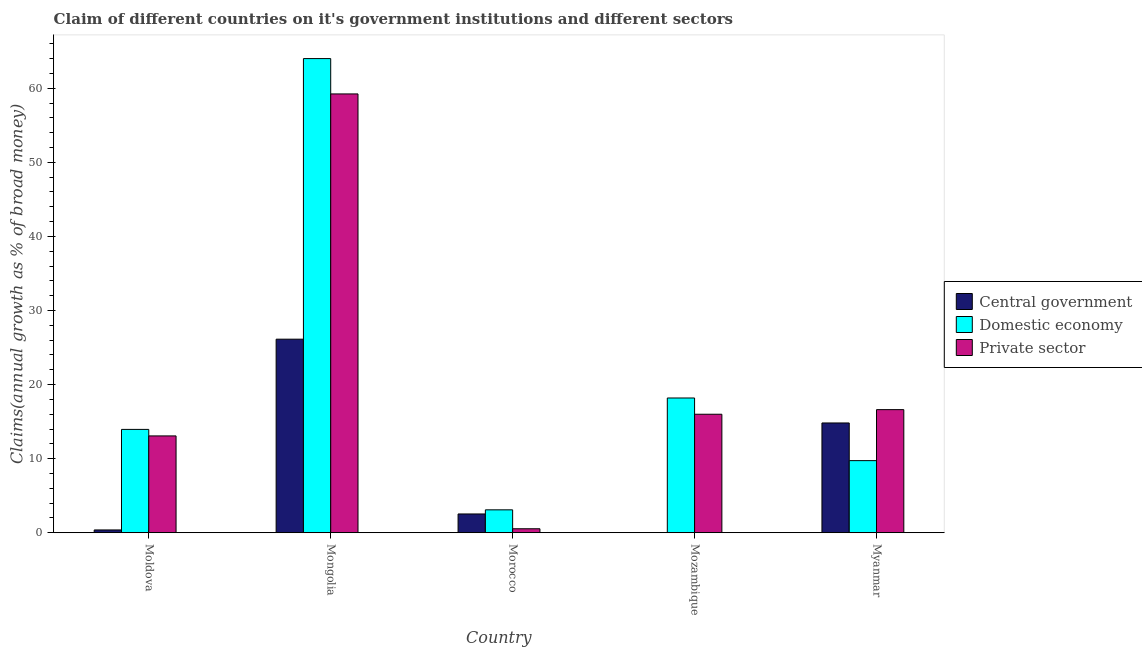How many different coloured bars are there?
Your answer should be very brief. 3. How many groups of bars are there?
Make the answer very short. 5. Are the number of bars on each tick of the X-axis equal?
Offer a terse response. No. How many bars are there on the 2nd tick from the left?
Provide a succinct answer. 3. What is the label of the 5th group of bars from the left?
Ensure brevity in your answer.  Myanmar. What is the percentage of claim on the domestic economy in Myanmar?
Your response must be concise. 9.73. Across all countries, what is the maximum percentage of claim on the central government?
Keep it short and to the point. 26.13. Across all countries, what is the minimum percentage of claim on the private sector?
Provide a short and direct response. 0.53. In which country was the percentage of claim on the private sector maximum?
Provide a short and direct response. Mongolia. What is the total percentage of claim on the private sector in the graph?
Keep it short and to the point. 105.45. What is the difference between the percentage of claim on the central government in Moldova and that in Mongolia?
Ensure brevity in your answer.  -25.75. What is the difference between the percentage of claim on the domestic economy in Moldova and the percentage of claim on the private sector in Mongolia?
Offer a terse response. -45.29. What is the average percentage of claim on the domestic economy per country?
Offer a very short reply. 21.79. What is the difference between the percentage of claim on the central government and percentage of claim on the domestic economy in Morocco?
Your answer should be very brief. -0.56. What is the ratio of the percentage of claim on the central government in Mongolia to that in Morocco?
Offer a very short reply. 10.32. What is the difference between the highest and the second highest percentage of claim on the private sector?
Provide a succinct answer. 42.62. What is the difference between the highest and the lowest percentage of claim on the domestic economy?
Your answer should be very brief. 60.92. Is the sum of the percentage of claim on the central government in Mongolia and Myanmar greater than the maximum percentage of claim on the domestic economy across all countries?
Keep it short and to the point. No. Are all the bars in the graph horizontal?
Provide a succinct answer. No. How many countries are there in the graph?
Your answer should be very brief. 5. Are the values on the major ticks of Y-axis written in scientific E-notation?
Your answer should be compact. No. Does the graph contain any zero values?
Your answer should be compact. Yes. Where does the legend appear in the graph?
Your response must be concise. Center right. How are the legend labels stacked?
Your response must be concise. Vertical. What is the title of the graph?
Offer a terse response. Claim of different countries on it's government institutions and different sectors. Does "Profit Tax" appear as one of the legend labels in the graph?
Ensure brevity in your answer.  No. What is the label or title of the X-axis?
Give a very brief answer. Country. What is the label or title of the Y-axis?
Keep it short and to the point. Claims(annual growth as % of broad money). What is the Claims(annual growth as % of broad money) in Central government in Moldova?
Give a very brief answer. 0.37. What is the Claims(annual growth as % of broad money) of Domestic economy in Moldova?
Offer a very short reply. 13.95. What is the Claims(annual growth as % of broad money) in Private sector in Moldova?
Your answer should be very brief. 13.07. What is the Claims(annual growth as % of broad money) of Central government in Mongolia?
Your response must be concise. 26.13. What is the Claims(annual growth as % of broad money) in Domestic economy in Mongolia?
Offer a terse response. 64.01. What is the Claims(annual growth as % of broad money) of Private sector in Mongolia?
Ensure brevity in your answer.  59.24. What is the Claims(annual growth as % of broad money) in Central government in Morocco?
Your answer should be very brief. 2.53. What is the Claims(annual growth as % of broad money) in Domestic economy in Morocco?
Offer a very short reply. 3.09. What is the Claims(annual growth as % of broad money) of Private sector in Morocco?
Keep it short and to the point. 0.53. What is the Claims(annual growth as % of broad money) of Central government in Mozambique?
Your response must be concise. 0. What is the Claims(annual growth as % of broad money) in Domestic economy in Mozambique?
Make the answer very short. 18.19. What is the Claims(annual growth as % of broad money) in Private sector in Mozambique?
Your answer should be very brief. 15.99. What is the Claims(annual growth as % of broad money) of Central government in Myanmar?
Your response must be concise. 14.82. What is the Claims(annual growth as % of broad money) in Domestic economy in Myanmar?
Your answer should be very brief. 9.73. What is the Claims(annual growth as % of broad money) in Private sector in Myanmar?
Make the answer very short. 16.62. Across all countries, what is the maximum Claims(annual growth as % of broad money) in Central government?
Offer a terse response. 26.13. Across all countries, what is the maximum Claims(annual growth as % of broad money) in Domestic economy?
Offer a terse response. 64.01. Across all countries, what is the maximum Claims(annual growth as % of broad money) in Private sector?
Keep it short and to the point. 59.24. Across all countries, what is the minimum Claims(annual growth as % of broad money) in Domestic economy?
Your answer should be very brief. 3.09. Across all countries, what is the minimum Claims(annual growth as % of broad money) in Private sector?
Make the answer very short. 0.53. What is the total Claims(annual growth as % of broad money) of Central government in the graph?
Your response must be concise. 43.85. What is the total Claims(annual growth as % of broad money) in Domestic economy in the graph?
Offer a terse response. 108.97. What is the total Claims(annual growth as % of broad money) of Private sector in the graph?
Offer a very short reply. 105.45. What is the difference between the Claims(annual growth as % of broad money) of Central government in Moldova and that in Mongolia?
Your answer should be very brief. -25.75. What is the difference between the Claims(annual growth as % of broad money) in Domestic economy in Moldova and that in Mongolia?
Make the answer very short. -50.06. What is the difference between the Claims(annual growth as % of broad money) of Private sector in Moldova and that in Mongolia?
Provide a succinct answer. -46.17. What is the difference between the Claims(annual growth as % of broad money) in Central government in Moldova and that in Morocco?
Provide a succinct answer. -2.16. What is the difference between the Claims(annual growth as % of broad money) of Domestic economy in Moldova and that in Morocco?
Keep it short and to the point. 10.86. What is the difference between the Claims(annual growth as % of broad money) in Private sector in Moldova and that in Morocco?
Offer a terse response. 12.53. What is the difference between the Claims(annual growth as % of broad money) of Domestic economy in Moldova and that in Mozambique?
Your answer should be compact. -4.24. What is the difference between the Claims(annual growth as % of broad money) in Private sector in Moldova and that in Mozambique?
Give a very brief answer. -2.93. What is the difference between the Claims(annual growth as % of broad money) in Central government in Moldova and that in Myanmar?
Offer a very short reply. -14.44. What is the difference between the Claims(annual growth as % of broad money) in Domestic economy in Moldova and that in Myanmar?
Your response must be concise. 4.22. What is the difference between the Claims(annual growth as % of broad money) of Private sector in Moldova and that in Myanmar?
Provide a succinct answer. -3.55. What is the difference between the Claims(annual growth as % of broad money) of Central government in Mongolia and that in Morocco?
Give a very brief answer. 23.6. What is the difference between the Claims(annual growth as % of broad money) in Domestic economy in Mongolia and that in Morocco?
Ensure brevity in your answer.  60.92. What is the difference between the Claims(annual growth as % of broad money) in Private sector in Mongolia and that in Morocco?
Offer a terse response. 58.71. What is the difference between the Claims(annual growth as % of broad money) of Domestic economy in Mongolia and that in Mozambique?
Your response must be concise. 45.82. What is the difference between the Claims(annual growth as % of broad money) in Private sector in Mongolia and that in Mozambique?
Offer a terse response. 43.24. What is the difference between the Claims(annual growth as % of broad money) in Central government in Mongolia and that in Myanmar?
Keep it short and to the point. 11.31. What is the difference between the Claims(annual growth as % of broad money) in Domestic economy in Mongolia and that in Myanmar?
Provide a short and direct response. 54.28. What is the difference between the Claims(annual growth as % of broad money) in Private sector in Mongolia and that in Myanmar?
Provide a succinct answer. 42.62. What is the difference between the Claims(annual growth as % of broad money) in Domestic economy in Morocco and that in Mozambique?
Offer a terse response. -15.1. What is the difference between the Claims(annual growth as % of broad money) in Private sector in Morocco and that in Mozambique?
Provide a succinct answer. -15.46. What is the difference between the Claims(annual growth as % of broad money) of Central government in Morocco and that in Myanmar?
Offer a terse response. -12.28. What is the difference between the Claims(annual growth as % of broad money) in Domestic economy in Morocco and that in Myanmar?
Offer a terse response. -6.64. What is the difference between the Claims(annual growth as % of broad money) in Private sector in Morocco and that in Myanmar?
Your answer should be compact. -16.08. What is the difference between the Claims(annual growth as % of broad money) of Domestic economy in Mozambique and that in Myanmar?
Give a very brief answer. 8.46. What is the difference between the Claims(annual growth as % of broad money) in Private sector in Mozambique and that in Myanmar?
Your answer should be compact. -0.62. What is the difference between the Claims(annual growth as % of broad money) in Central government in Moldova and the Claims(annual growth as % of broad money) in Domestic economy in Mongolia?
Ensure brevity in your answer.  -63.64. What is the difference between the Claims(annual growth as % of broad money) in Central government in Moldova and the Claims(annual growth as % of broad money) in Private sector in Mongolia?
Keep it short and to the point. -58.86. What is the difference between the Claims(annual growth as % of broad money) in Domestic economy in Moldova and the Claims(annual growth as % of broad money) in Private sector in Mongolia?
Ensure brevity in your answer.  -45.29. What is the difference between the Claims(annual growth as % of broad money) of Central government in Moldova and the Claims(annual growth as % of broad money) of Domestic economy in Morocco?
Ensure brevity in your answer.  -2.72. What is the difference between the Claims(annual growth as % of broad money) of Central government in Moldova and the Claims(annual growth as % of broad money) of Private sector in Morocco?
Offer a terse response. -0.16. What is the difference between the Claims(annual growth as % of broad money) in Domestic economy in Moldova and the Claims(annual growth as % of broad money) in Private sector in Morocco?
Offer a very short reply. 13.41. What is the difference between the Claims(annual growth as % of broad money) of Central government in Moldova and the Claims(annual growth as % of broad money) of Domestic economy in Mozambique?
Ensure brevity in your answer.  -17.82. What is the difference between the Claims(annual growth as % of broad money) of Central government in Moldova and the Claims(annual growth as % of broad money) of Private sector in Mozambique?
Make the answer very short. -15.62. What is the difference between the Claims(annual growth as % of broad money) of Domestic economy in Moldova and the Claims(annual growth as % of broad money) of Private sector in Mozambique?
Your answer should be compact. -2.05. What is the difference between the Claims(annual growth as % of broad money) in Central government in Moldova and the Claims(annual growth as % of broad money) in Domestic economy in Myanmar?
Ensure brevity in your answer.  -9.36. What is the difference between the Claims(annual growth as % of broad money) in Central government in Moldova and the Claims(annual growth as % of broad money) in Private sector in Myanmar?
Offer a terse response. -16.24. What is the difference between the Claims(annual growth as % of broad money) in Domestic economy in Moldova and the Claims(annual growth as % of broad money) in Private sector in Myanmar?
Ensure brevity in your answer.  -2.67. What is the difference between the Claims(annual growth as % of broad money) in Central government in Mongolia and the Claims(annual growth as % of broad money) in Domestic economy in Morocco?
Your answer should be compact. 23.04. What is the difference between the Claims(annual growth as % of broad money) in Central government in Mongolia and the Claims(annual growth as % of broad money) in Private sector in Morocco?
Provide a short and direct response. 25.59. What is the difference between the Claims(annual growth as % of broad money) in Domestic economy in Mongolia and the Claims(annual growth as % of broad money) in Private sector in Morocco?
Your response must be concise. 63.48. What is the difference between the Claims(annual growth as % of broad money) of Central government in Mongolia and the Claims(annual growth as % of broad money) of Domestic economy in Mozambique?
Your answer should be very brief. 7.94. What is the difference between the Claims(annual growth as % of broad money) of Central government in Mongolia and the Claims(annual growth as % of broad money) of Private sector in Mozambique?
Your answer should be compact. 10.13. What is the difference between the Claims(annual growth as % of broad money) of Domestic economy in Mongolia and the Claims(annual growth as % of broad money) of Private sector in Mozambique?
Ensure brevity in your answer.  48.02. What is the difference between the Claims(annual growth as % of broad money) of Central government in Mongolia and the Claims(annual growth as % of broad money) of Domestic economy in Myanmar?
Keep it short and to the point. 16.4. What is the difference between the Claims(annual growth as % of broad money) of Central government in Mongolia and the Claims(annual growth as % of broad money) of Private sector in Myanmar?
Keep it short and to the point. 9.51. What is the difference between the Claims(annual growth as % of broad money) of Domestic economy in Mongolia and the Claims(annual growth as % of broad money) of Private sector in Myanmar?
Provide a succinct answer. 47.39. What is the difference between the Claims(annual growth as % of broad money) of Central government in Morocco and the Claims(annual growth as % of broad money) of Domestic economy in Mozambique?
Your answer should be compact. -15.66. What is the difference between the Claims(annual growth as % of broad money) of Central government in Morocco and the Claims(annual growth as % of broad money) of Private sector in Mozambique?
Your answer should be compact. -13.46. What is the difference between the Claims(annual growth as % of broad money) in Domestic economy in Morocco and the Claims(annual growth as % of broad money) in Private sector in Mozambique?
Offer a very short reply. -12.91. What is the difference between the Claims(annual growth as % of broad money) in Central government in Morocco and the Claims(annual growth as % of broad money) in Domestic economy in Myanmar?
Your answer should be compact. -7.2. What is the difference between the Claims(annual growth as % of broad money) of Central government in Morocco and the Claims(annual growth as % of broad money) of Private sector in Myanmar?
Your answer should be very brief. -14.08. What is the difference between the Claims(annual growth as % of broad money) of Domestic economy in Morocco and the Claims(annual growth as % of broad money) of Private sector in Myanmar?
Your response must be concise. -13.53. What is the difference between the Claims(annual growth as % of broad money) in Domestic economy in Mozambique and the Claims(annual growth as % of broad money) in Private sector in Myanmar?
Your response must be concise. 1.57. What is the average Claims(annual growth as % of broad money) in Central government per country?
Your answer should be very brief. 8.77. What is the average Claims(annual growth as % of broad money) in Domestic economy per country?
Ensure brevity in your answer.  21.79. What is the average Claims(annual growth as % of broad money) of Private sector per country?
Make the answer very short. 21.09. What is the difference between the Claims(annual growth as % of broad money) of Central government and Claims(annual growth as % of broad money) of Domestic economy in Moldova?
Give a very brief answer. -13.57. What is the difference between the Claims(annual growth as % of broad money) in Central government and Claims(annual growth as % of broad money) in Private sector in Moldova?
Ensure brevity in your answer.  -12.69. What is the difference between the Claims(annual growth as % of broad money) of Domestic economy and Claims(annual growth as % of broad money) of Private sector in Moldova?
Provide a succinct answer. 0.88. What is the difference between the Claims(annual growth as % of broad money) in Central government and Claims(annual growth as % of broad money) in Domestic economy in Mongolia?
Give a very brief answer. -37.88. What is the difference between the Claims(annual growth as % of broad money) of Central government and Claims(annual growth as % of broad money) of Private sector in Mongolia?
Offer a very short reply. -33.11. What is the difference between the Claims(annual growth as % of broad money) of Domestic economy and Claims(annual growth as % of broad money) of Private sector in Mongolia?
Ensure brevity in your answer.  4.77. What is the difference between the Claims(annual growth as % of broad money) of Central government and Claims(annual growth as % of broad money) of Domestic economy in Morocco?
Ensure brevity in your answer.  -0.56. What is the difference between the Claims(annual growth as % of broad money) of Central government and Claims(annual growth as % of broad money) of Private sector in Morocco?
Give a very brief answer. 2. What is the difference between the Claims(annual growth as % of broad money) of Domestic economy and Claims(annual growth as % of broad money) of Private sector in Morocco?
Offer a very short reply. 2.56. What is the difference between the Claims(annual growth as % of broad money) in Domestic economy and Claims(annual growth as % of broad money) in Private sector in Mozambique?
Give a very brief answer. 2.19. What is the difference between the Claims(annual growth as % of broad money) of Central government and Claims(annual growth as % of broad money) of Domestic economy in Myanmar?
Provide a short and direct response. 5.08. What is the difference between the Claims(annual growth as % of broad money) of Central government and Claims(annual growth as % of broad money) of Private sector in Myanmar?
Give a very brief answer. -1.8. What is the difference between the Claims(annual growth as % of broad money) of Domestic economy and Claims(annual growth as % of broad money) of Private sector in Myanmar?
Provide a short and direct response. -6.88. What is the ratio of the Claims(annual growth as % of broad money) in Central government in Moldova to that in Mongolia?
Ensure brevity in your answer.  0.01. What is the ratio of the Claims(annual growth as % of broad money) in Domestic economy in Moldova to that in Mongolia?
Your answer should be compact. 0.22. What is the ratio of the Claims(annual growth as % of broad money) in Private sector in Moldova to that in Mongolia?
Your answer should be very brief. 0.22. What is the ratio of the Claims(annual growth as % of broad money) of Central government in Moldova to that in Morocco?
Provide a succinct answer. 0.15. What is the ratio of the Claims(annual growth as % of broad money) of Domestic economy in Moldova to that in Morocco?
Your answer should be very brief. 4.52. What is the ratio of the Claims(annual growth as % of broad money) in Private sector in Moldova to that in Morocco?
Keep it short and to the point. 24.53. What is the ratio of the Claims(annual growth as % of broad money) in Domestic economy in Moldova to that in Mozambique?
Provide a succinct answer. 0.77. What is the ratio of the Claims(annual growth as % of broad money) in Private sector in Moldova to that in Mozambique?
Your response must be concise. 0.82. What is the ratio of the Claims(annual growth as % of broad money) of Central government in Moldova to that in Myanmar?
Keep it short and to the point. 0.03. What is the ratio of the Claims(annual growth as % of broad money) of Domestic economy in Moldova to that in Myanmar?
Provide a short and direct response. 1.43. What is the ratio of the Claims(annual growth as % of broad money) in Private sector in Moldova to that in Myanmar?
Your response must be concise. 0.79. What is the ratio of the Claims(annual growth as % of broad money) in Central government in Mongolia to that in Morocco?
Your answer should be compact. 10.32. What is the ratio of the Claims(annual growth as % of broad money) of Domestic economy in Mongolia to that in Morocco?
Ensure brevity in your answer.  20.72. What is the ratio of the Claims(annual growth as % of broad money) in Private sector in Mongolia to that in Morocco?
Give a very brief answer. 111.22. What is the ratio of the Claims(annual growth as % of broad money) in Domestic economy in Mongolia to that in Mozambique?
Your answer should be compact. 3.52. What is the ratio of the Claims(annual growth as % of broad money) of Private sector in Mongolia to that in Mozambique?
Your answer should be very brief. 3.7. What is the ratio of the Claims(annual growth as % of broad money) in Central government in Mongolia to that in Myanmar?
Offer a terse response. 1.76. What is the ratio of the Claims(annual growth as % of broad money) in Domestic economy in Mongolia to that in Myanmar?
Give a very brief answer. 6.58. What is the ratio of the Claims(annual growth as % of broad money) in Private sector in Mongolia to that in Myanmar?
Keep it short and to the point. 3.57. What is the ratio of the Claims(annual growth as % of broad money) of Domestic economy in Morocco to that in Mozambique?
Ensure brevity in your answer.  0.17. What is the ratio of the Claims(annual growth as % of broad money) in Private sector in Morocco to that in Mozambique?
Your answer should be very brief. 0.03. What is the ratio of the Claims(annual growth as % of broad money) in Central government in Morocco to that in Myanmar?
Offer a terse response. 0.17. What is the ratio of the Claims(annual growth as % of broad money) in Domestic economy in Morocco to that in Myanmar?
Offer a terse response. 0.32. What is the ratio of the Claims(annual growth as % of broad money) in Private sector in Morocco to that in Myanmar?
Keep it short and to the point. 0.03. What is the ratio of the Claims(annual growth as % of broad money) of Domestic economy in Mozambique to that in Myanmar?
Provide a short and direct response. 1.87. What is the ratio of the Claims(annual growth as % of broad money) of Private sector in Mozambique to that in Myanmar?
Make the answer very short. 0.96. What is the difference between the highest and the second highest Claims(annual growth as % of broad money) in Central government?
Offer a very short reply. 11.31. What is the difference between the highest and the second highest Claims(annual growth as % of broad money) of Domestic economy?
Offer a very short reply. 45.82. What is the difference between the highest and the second highest Claims(annual growth as % of broad money) in Private sector?
Provide a succinct answer. 42.62. What is the difference between the highest and the lowest Claims(annual growth as % of broad money) in Central government?
Your answer should be very brief. 26.13. What is the difference between the highest and the lowest Claims(annual growth as % of broad money) of Domestic economy?
Make the answer very short. 60.92. What is the difference between the highest and the lowest Claims(annual growth as % of broad money) of Private sector?
Provide a short and direct response. 58.71. 